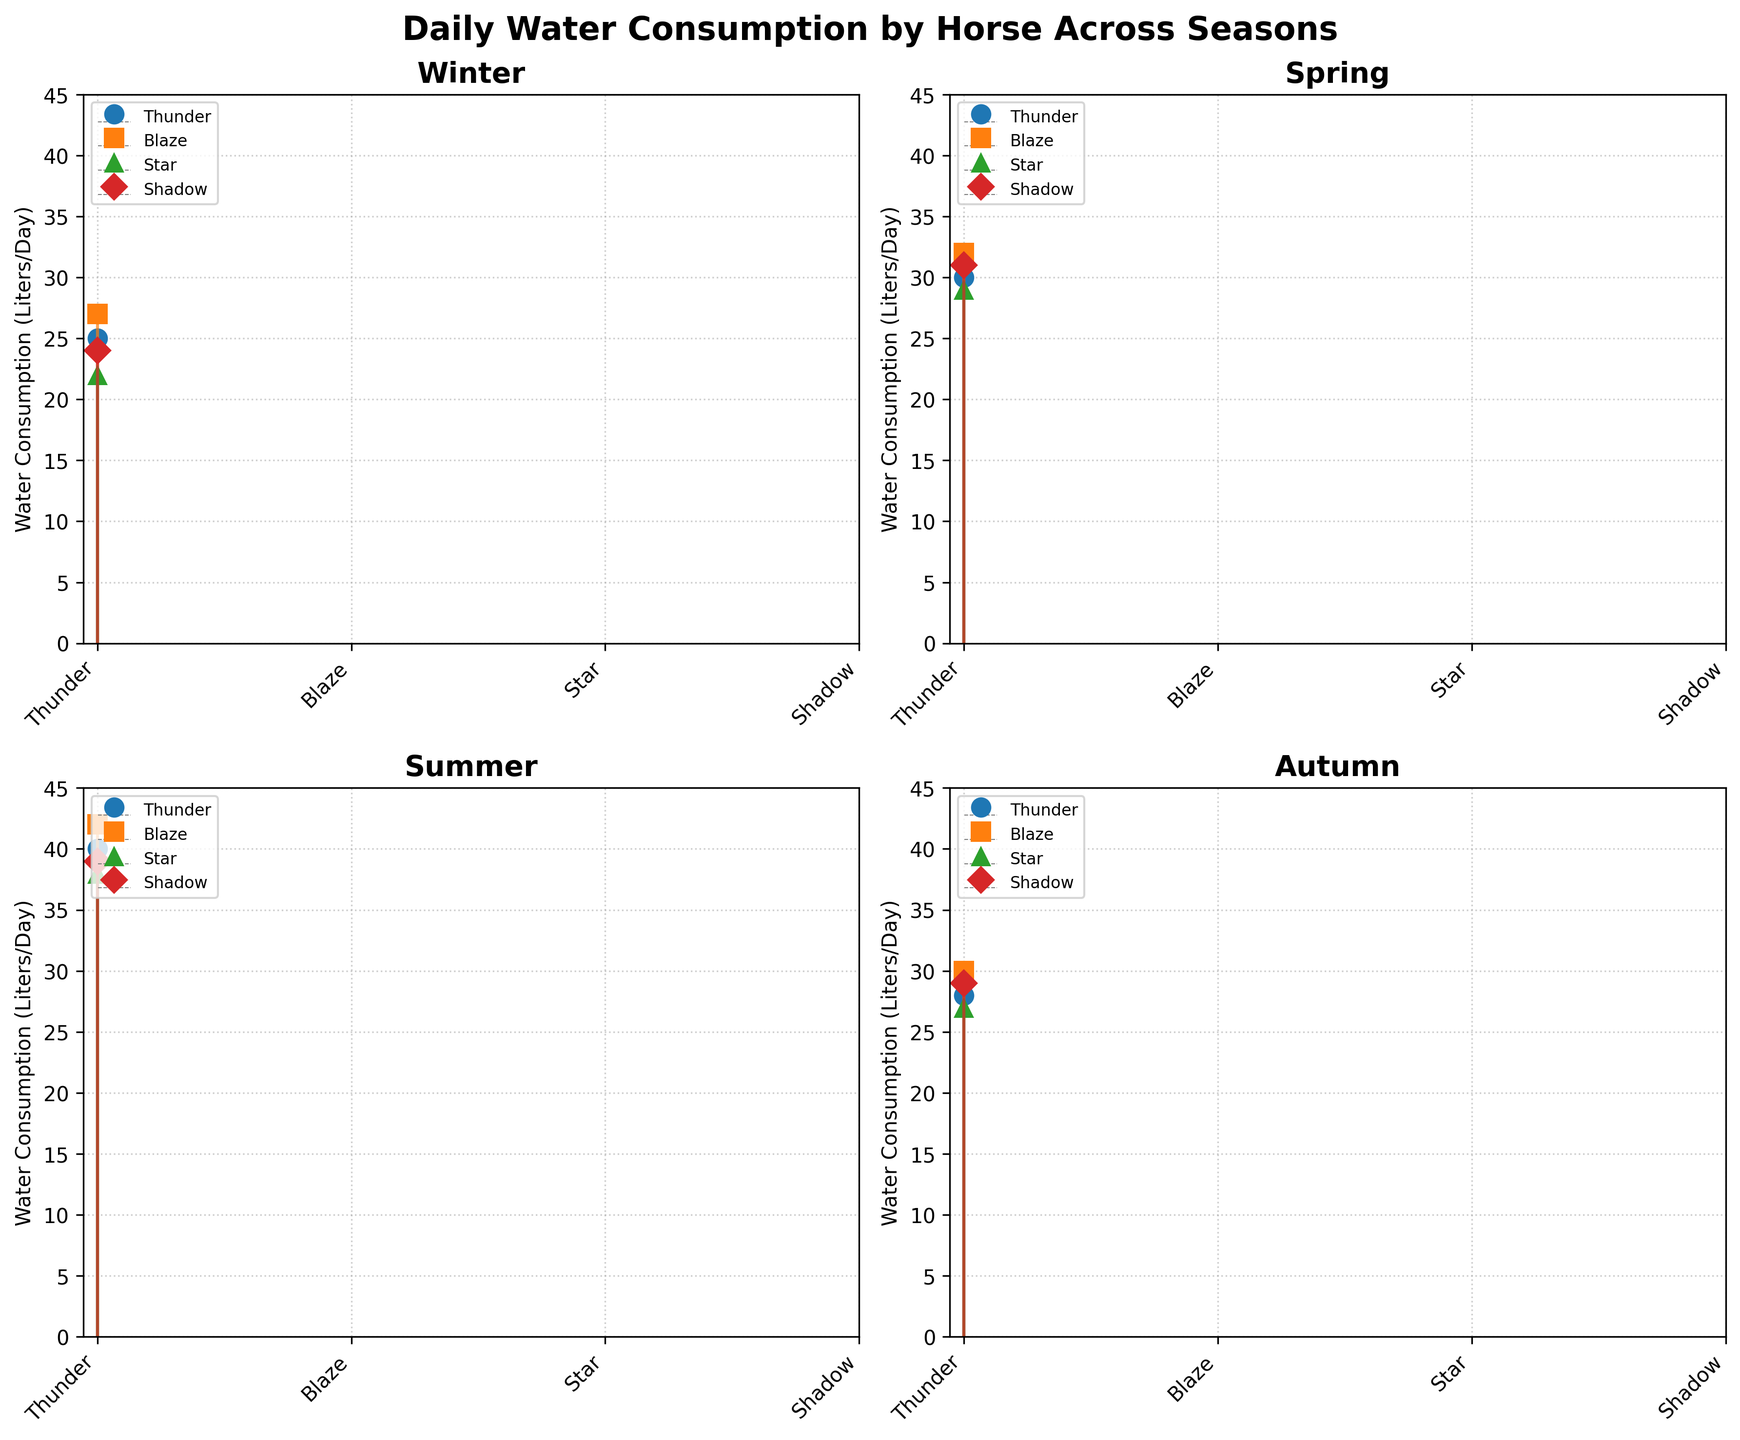How many horses are being tracked in each season? Each subplot corresponds to a season and tracks four separate horses (Thunder, Blaze, Star, Shadow).
Answer: 4 Which horse consumes the most water in the summer? In the summer subplot, the horse with the highest water consumption is Blaze, with 42 liters per day.
Answer: Blaze What is the total water consumption by Shadow in all seasons? Sum Shadow's water consumption across all seasons: Winter (24) + Spring (31) + Summer (39) + Autumn (29). The total is 24 + 31 + 39 + 29 = 123 liters.
Answer: 123 liters Which season shows the highest overall water consumption across all horses? By visually comparing the peaks in each subplot: Winter, Spring, Summer, and Autumn, the Summer plot shows peaks near or above 38 liters, indicating the highest consumption.
Answer: Summer Is there any horse whose water consumption does not vary much across seasons? By examining each horse across subplots, Thunder shows water consumption of 25, 30, 40, and 28 liters, indicating some variance. Shadow has lower variance with 24, 31, 39, and 29; Blaze and Star also show more noticeable variations.
Answer: No What is the range of water consumption for Star in Spring? In Spring, Star's water consumption is 29 liters per day. Since there is only one value, the range is 0.
Answer: 0 liters Which season has the lowest water consumption for Thunder? Look at Thunder's water consumption in each season: 25 (Winter), 30 (Spring), 40 (Summer), 28 (Autumn). The lowest value is in Winter.
Answer: Winter What’s the difference in water consumption between Blaze and Star in Autumn? In Autumn, Blaze consumes 30 liters per day, and Star consumes 27 liters per day. The difference is 30 - 27 = 3 liters.
Answer: 3 liters Which horse shows the highest increase in water consumption from Winter to Summer? For each horse, calculate the difference in consumption from Winter to Summer: Thunder (40-25=15), Blaze (42-27=15), Star (38-22=16), Shadow (39-24=15). Star shows the highest increase of 16 liters.
Answer: Star What is the average water consumption of all horses in Spring? Sum the water consumption of all horses in Spring: Thunder (30) + Blaze (32) + Star (29) + Shadow (31). The total is 30 + 32 + 29 + 31 = 122. The average is 122/4 = 30.5 liters.
Answer: 30.5 liters 